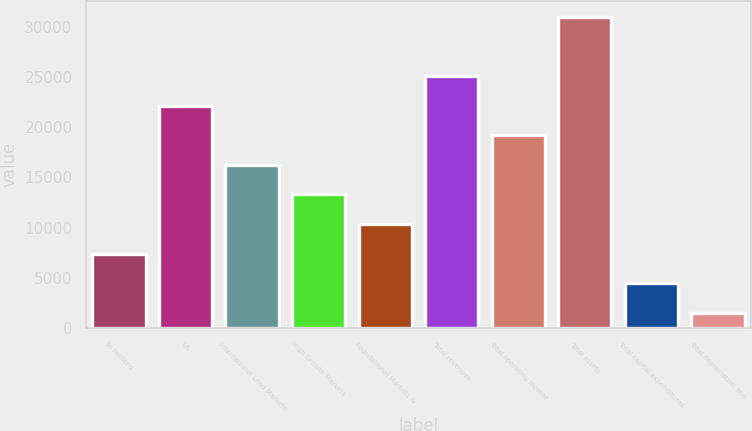<chart> <loc_0><loc_0><loc_500><loc_500><bar_chart><fcel>In millions<fcel>US<fcel>International Lead Markets<fcel>High Growth Markets<fcel>Foundational Markets &<fcel>Total revenues<fcel>Total operating income<fcel>Total assets<fcel>Total capital expenditures<fcel>Total depreciation and<nl><fcel>7417.98<fcel>22171.7<fcel>16270.2<fcel>13319.5<fcel>10368.7<fcel>25122.4<fcel>19220.9<fcel>31023.9<fcel>4467.24<fcel>1516.5<nl></chart> 